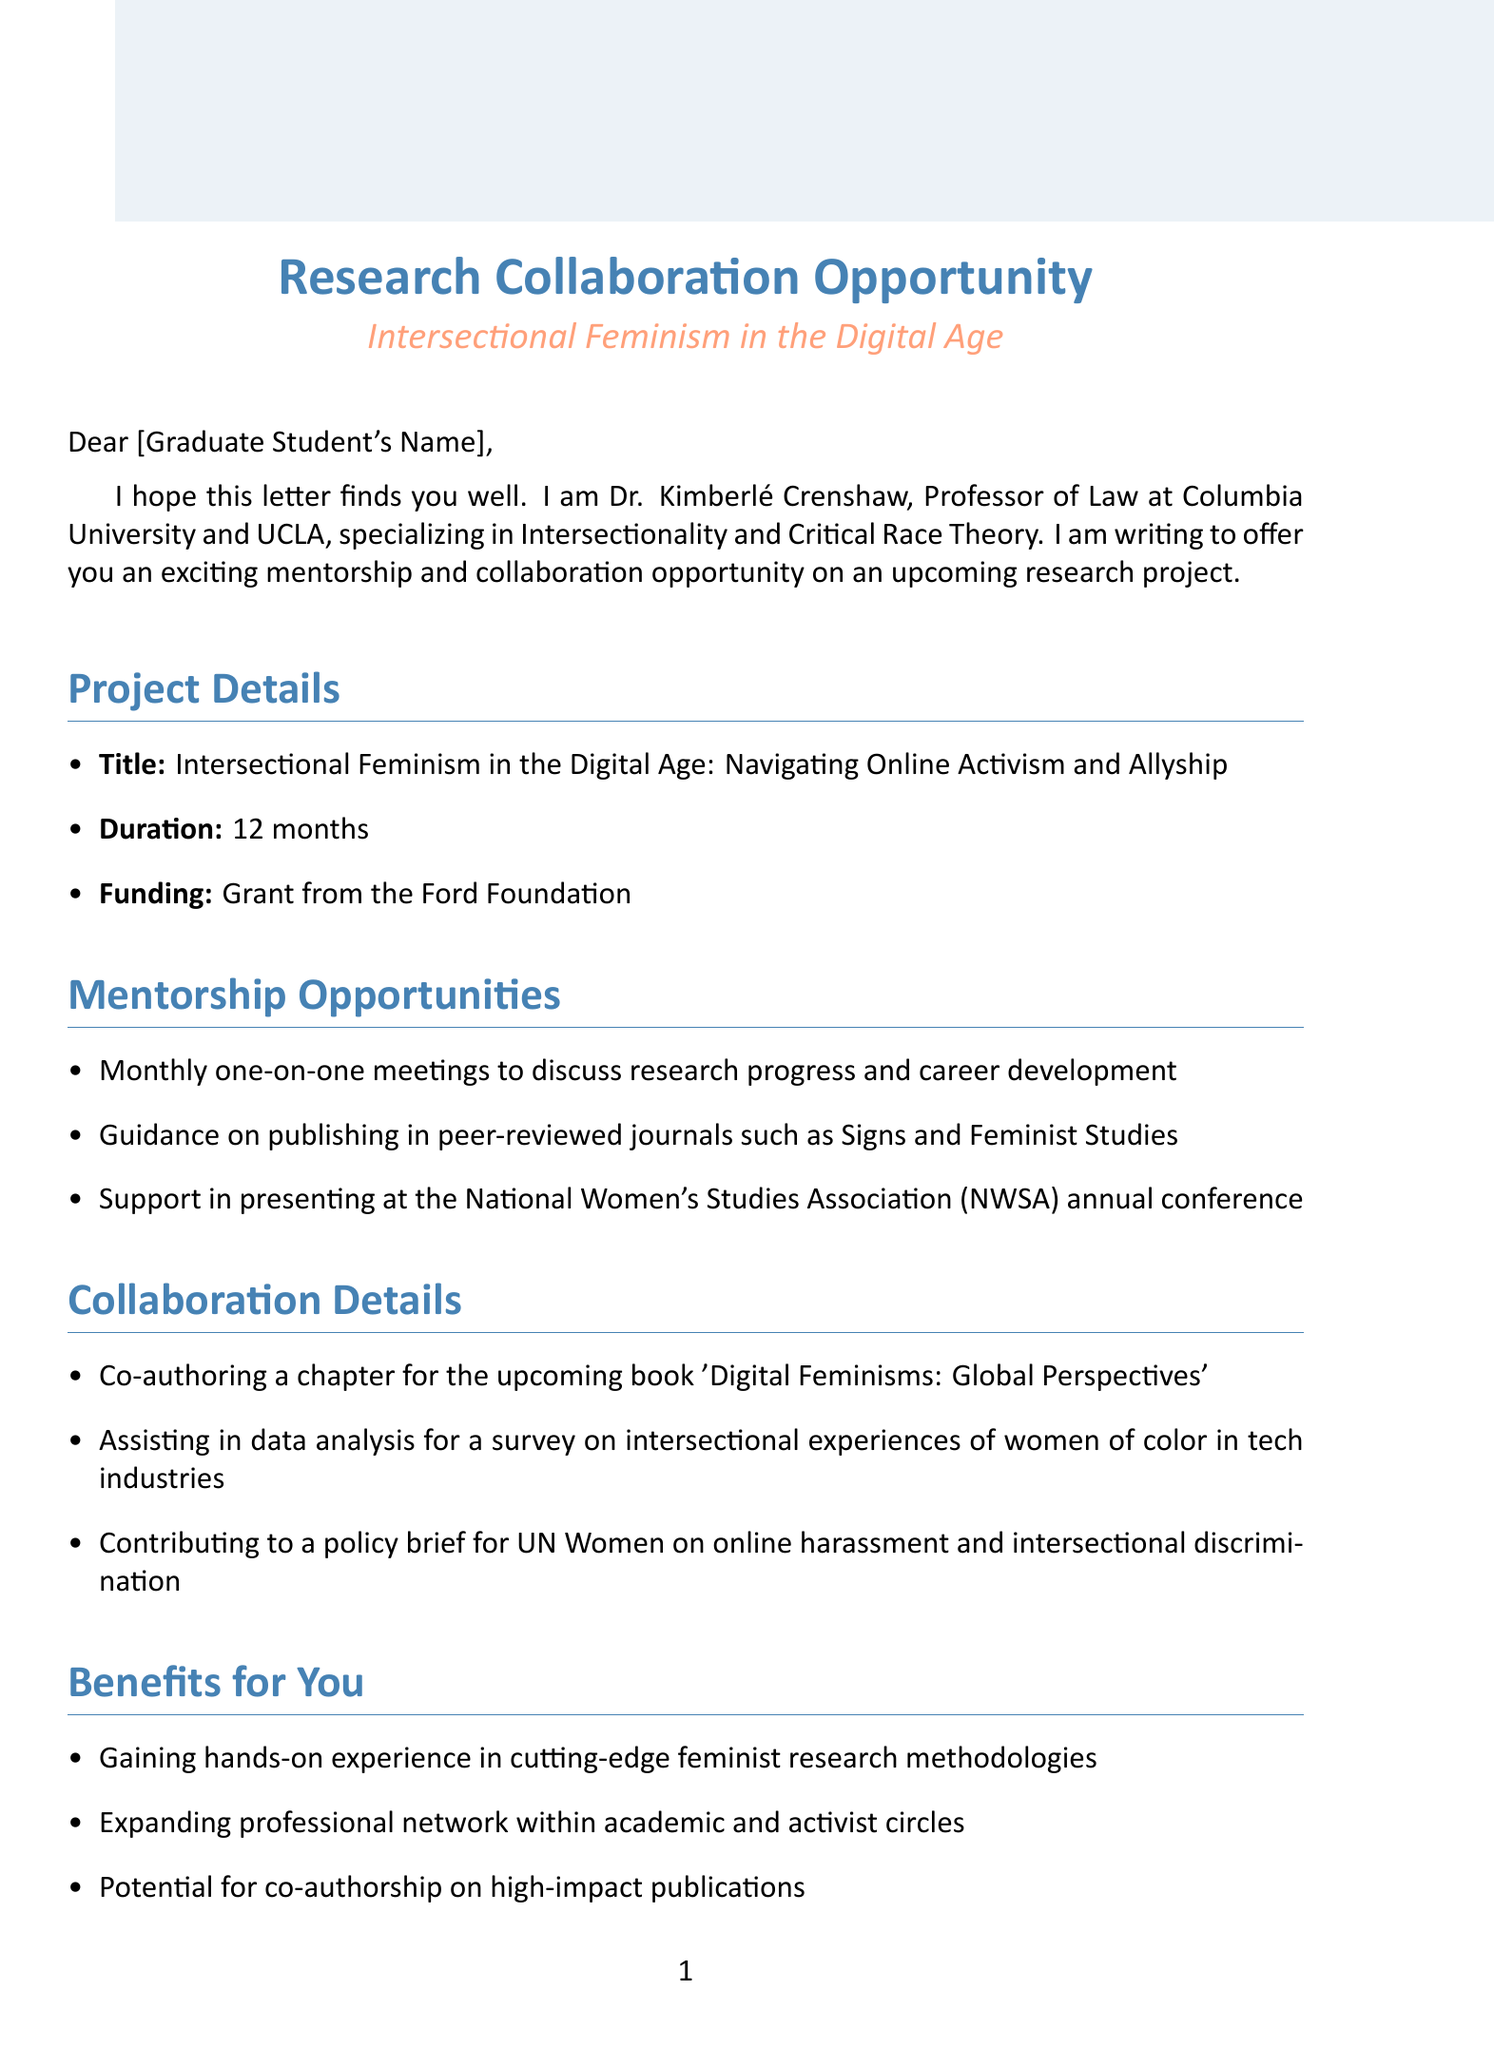what is the title of the research project? The title of the research project is explicitly stated in the document.
Answer: Intersectional Feminism in the Digital Age: Navigating Online Activism and Allyship who is the sender of the letter? The sender's name and title are provided at the beginning of the letter.
Answer: Dr. Kimberlé Crenshaw how long is the duration of the research project? The duration is mentioned in the project details section of the document.
Answer: 12 months what type of grant is funding the research project? The funding source is explicitly outlined in the project details section.
Answer: Grant from the Ford Foundation what is one of the mentorship opportunities offered? The mentorship opportunities are listed in a bullet format, one of which can be directly quoted.
Answer: Monthly one-on-one meetings to discuss research progress and career development what are two collaboration details mentioned in the letter? Two of the collaboration details are included in a list format in the document.
Answer: Co-authoring a chapter for the upcoming book 'Digital Feminisms: Global Perspectives' and Assisting in data analysis for a survey on intersectional experiences of women of color in tech industries what benefits can the student expect from this collaboration? The benefits for the student are outlined in the document and can be quoted as such.
Answer: Gaining hands-on experience in cutting-edge feminist research methodologies what are the next steps proposed in the letter? The next steps are listed in a numbered format and include specific actions.
Answer: Schedule an initial meeting to discuss project details and expectations what is the expectation expressed by the sender regarding collaboration? The closing remarks convey the sender's anticipation for the collaboration.
Answer: Excited about the potential of this collaboration and your unique perspective as a graduate student in gender studies 